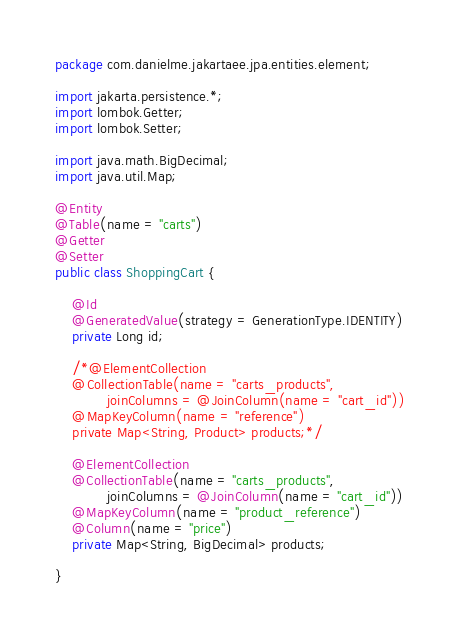Convert code to text. <code><loc_0><loc_0><loc_500><loc_500><_Java_>package com.danielme.jakartaee.jpa.entities.element;

import jakarta.persistence.*;
import lombok.Getter;
import lombok.Setter;

import java.math.BigDecimal;
import java.util.Map;

@Entity
@Table(name = "carts")
@Getter
@Setter
public class ShoppingCart {

    @Id
    @GeneratedValue(strategy = GenerationType.IDENTITY)
    private Long id;

    /*@ElementCollection
    @CollectionTable(name = "carts_products",
            joinColumns = @JoinColumn(name = "cart_id"))
    @MapKeyColumn(name = "reference")
    private Map<String, Product> products;*/

    @ElementCollection
    @CollectionTable(name = "carts_products",
            joinColumns = @JoinColumn(name = "cart_id"))
    @MapKeyColumn(name = "product_reference")
    @Column(name = "price")
    private Map<String, BigDecimal> products;

}
</code> 